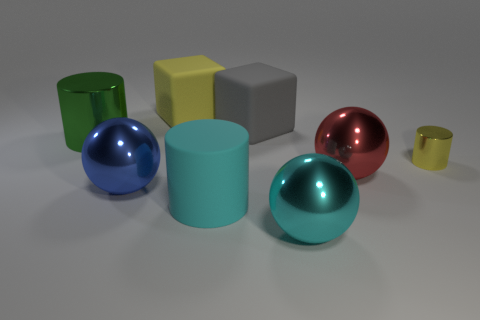What size is the shiny sphere to the left of the cylinder that is in front of the sphere that is on the left side of the big gray object?
Make the answer very short. Large. What color is the small metallic cylinder?
Your answer should be compact. Yellow. Is the number of objects that are right of the green shiny object greater than the number of yellow metallic balls?
Your answer should be very brief. Yes. How many green metallic cylinders are behind the gray thing?
Ensure brevity in your answer.  0. What shape is the large thing that is the same color as the big matte cylinder?
Your response must be concise. Sphere. There is a block that is in front of the rubber object that is behind the gray cube; is there a cyan object right of it?
Your response must be concise. Yes. Do the green cylinder and the yellow shiny cylinder have the same size?
Your answer should be compact. No. Are there the same number of red objects to the right of the red shiny thing and tiny objects that are in front of the cyan metal sphere?
Ensure brevity in your answer.  Yes. What is the shape of the large matte thing that is in front of the yellow metallic object?
Keep it short and to the point. Cylinder. There is a cyan matte thing that is the same size as the blue metal thing; what is its shape?
Keep it short and to the point. Cylinder. 